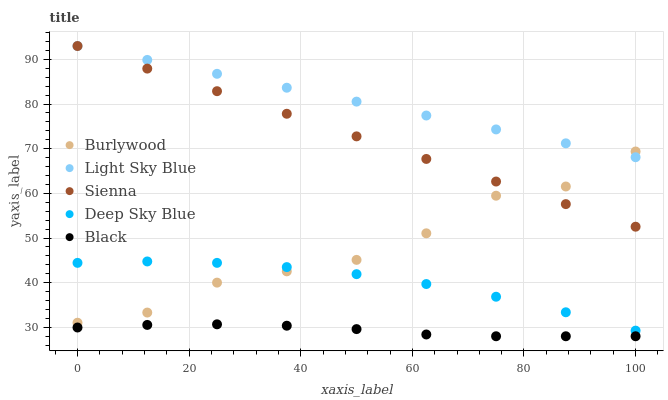Does Black have the minimum area under the curve?
Answer yes or no. Yes. Does Light Sky Blue have the maximum area under the curve?
Answer yes or no. Yes. Does Sienna have the minimum area under the curve?
Answer yes or no. No. Does Sienna have the maximum area under the curve?
Answer yes or no. No. Is Sienna the smoothest?
Answer yes or no. Yes. Is Burlywood the roughest?
Answer yes or no. Yes. Is Light Sky Blue the smoothest?
Answer yes or no. No. Is Light Sky Blue the roughest?
Answer yes or no. No. Does Black have the lowest value?
Answer yes or no. Yes. Does Sienna have the lowest value?
Answer yes or no. No. Does Light Sky Blue have the highest value?
Answer yes or no. Yes. Does Black have the highest value?
Answer yes or no. No. Is Black less than Deep Sky Blue?
Answer yes or no. Yes. Is Light Sky Blue greater than Black?
Answer yes or no. Yes. Does Sienna intersect Burlywood?
Answer yes or no. Yes. Is Sienna less than Burlywood?
Answer yes or no. No. Is Sienna greater than Burlywood?
Answer yes or no. No. Does Black intersect Deep Sky Blue?
Answer yes or no. No. 